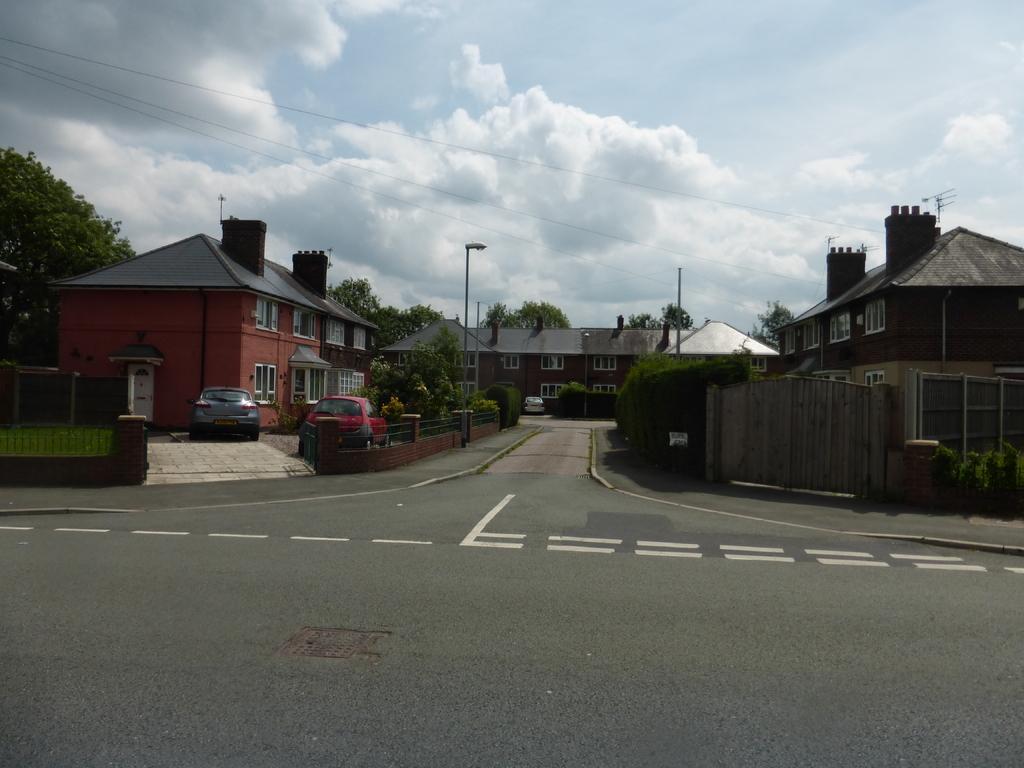Please provide a concise description of this image. In this image we can see group of vehicles parked on the ground. In the background, we can see buildings with windows and roofs, gate and fence. In the background, we can see light poles, group of trees and the sky. 